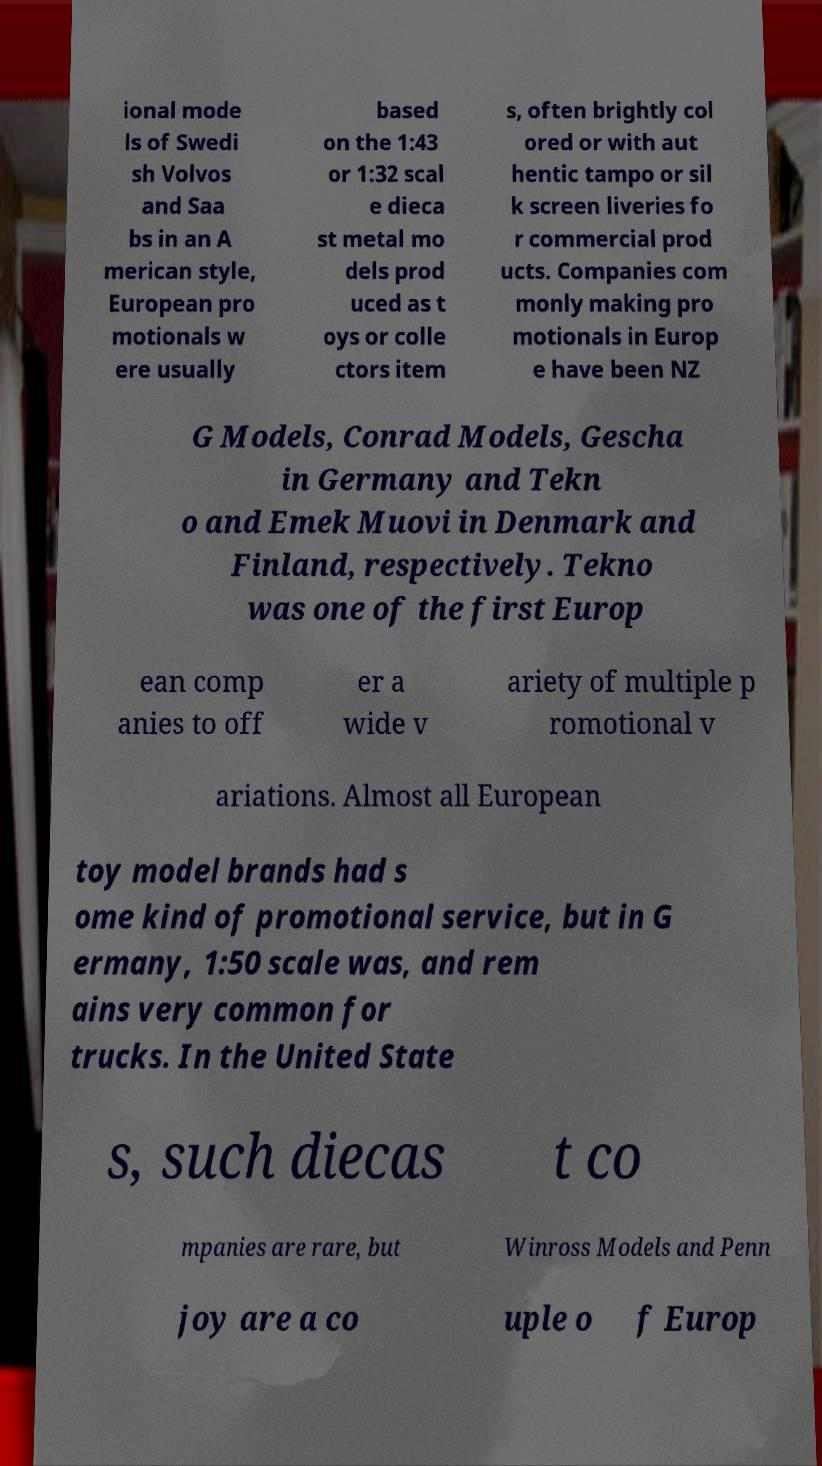Could you extract and type out the text from this image? ional mode ls of Swedi sh Volvos and Saa bs in an A merican style, European pro motionals w ere usually based on the 1:43 or 1:32 scal e dieca st metal mo dels prod uced as t oys or colle ctors item s, often brightly col ored or with aut hentic tampo or sil k screen liveries fo r commercial prod ucts. Companies com monly making pro motionals in Europ e have been NZ G Models, Conrad Models, Gescha in Germany and Tekn o and Emek Muovi in Denmark and Finland, respectively. Tekno was one of the first Europ ean comp anies to off er a wide v ariety of multiple p romotional v ariations. Almost all European toy model brands had s ome kind of promotional service, but in G ermany, 1:50 scale was, and rem ains very common for trucks. In the United State s, such diecas t co mpanies are rare, but Winross Models and Penn joy are a co uple o f Europ 